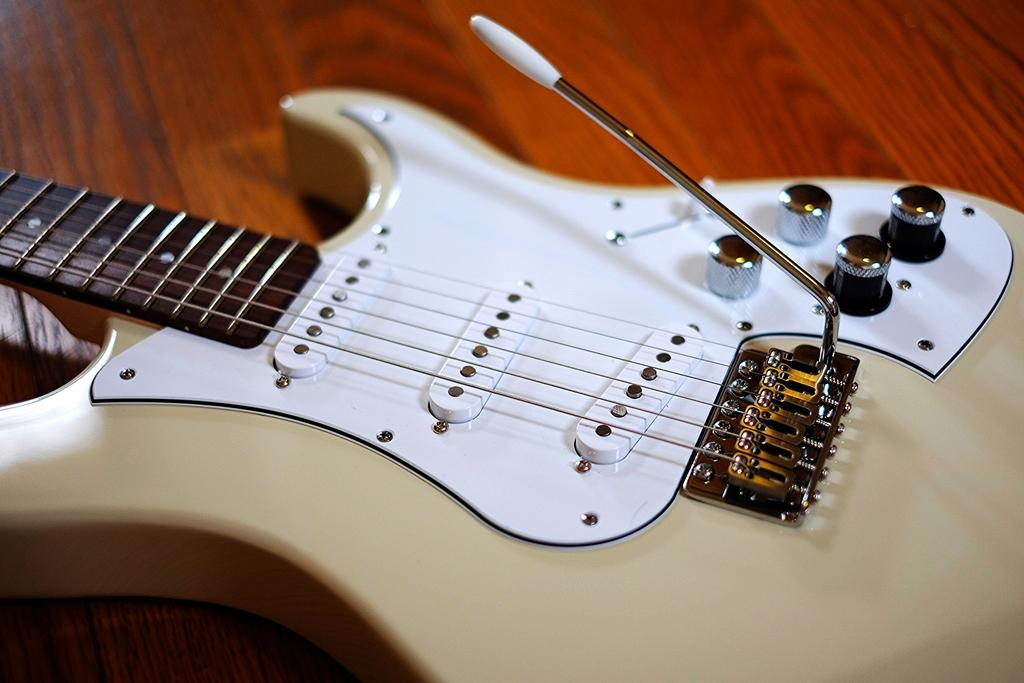What musical instrument is present in the image? There is a guitar in the image. What can be said about the color of the guitar? The guitar is colored. Where is the guitar located in the image? The guitar is placed on a table. What type of reaction does the bee have when it sees the guitar in the image? There is no bee present in the image, so it is not possible to determine its reaction to the guitar. 